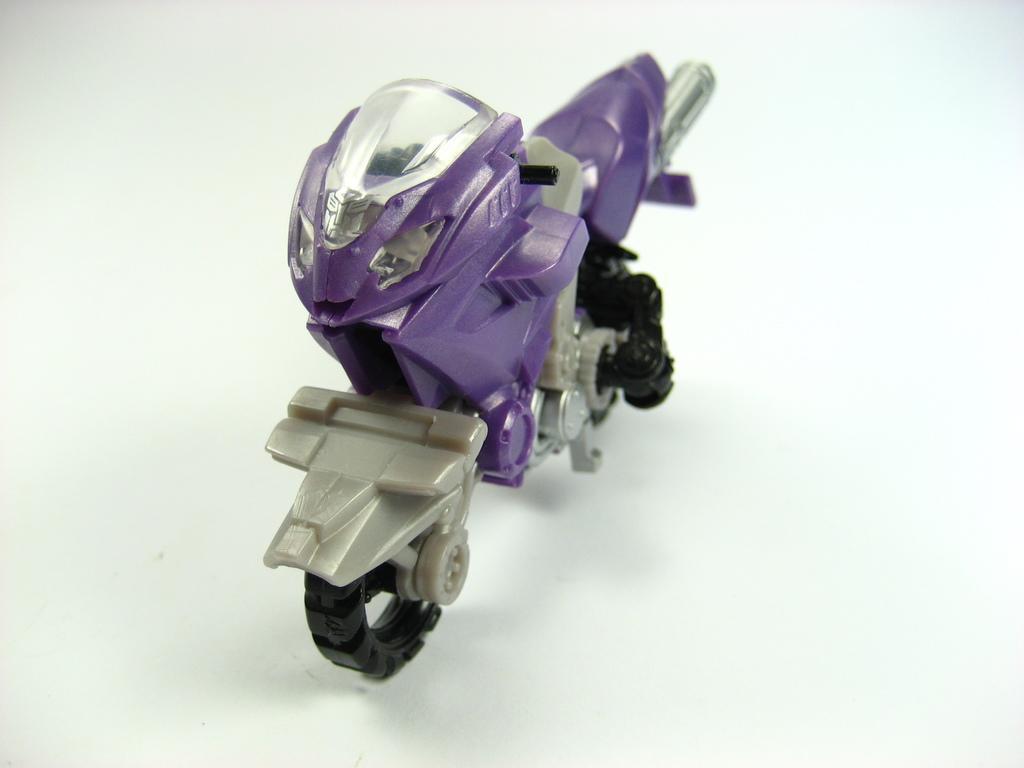Describe this image in one or two sentences. In this image there is a violet colour bike toy. Background is white in colour. 